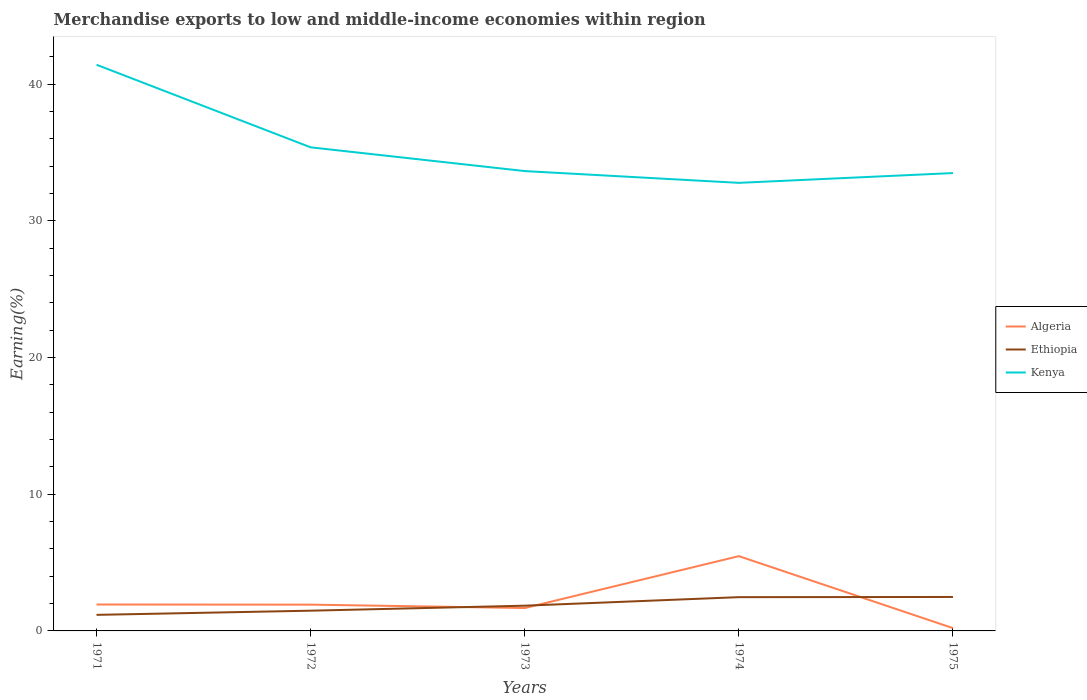How many different coloured lines are there?
Make the answer very short. 3. Across all years, what is the maximum percentage of amount earned from merchandise exports in Kenya?
Provide a short and direct response. 32.78. In which year was the percentage of amount earned from merchandise exports in Kenya maximum?
Provide a succinct answer. 1974. What is the total percentage of amount earned from merchandise exports in Kenya in the graph?
Your response must be concise. 0.86. What is the difference between the highest and the second highest percentage of amount earned from merchandise exports in Algeria?
Your answer should be very brief. 5.27. What is the difference between the highest and the lowest percentage of amount earned from merchandise exports in Ethiopia?
Ensure brevity in your answer.  2. How many lines are there?
Provide a succinct answer. 3. What is the difference between two consecutive major ticks on the Y-axis?
Provide a short and direct response. 10. Does the graph contain grids?
Give a very brief answer. No. Where does the legend appear in the graph?
Offer a terse response. Center right. What is the title of the graph?
Provide a short and direct response. Merchandise exports to low and middle-income economies within region. Does "Guam" appear as one of the legend labels in the graph?
Provide a short and direct response. No. What is the label or title of the Y-axis?
Offer a very short reply. Earning(%). What is the Earning(%) of Algeria in 1971?
Offer a very short reply. 1.93. What is the Earning(%) in Ethiopia in 1971?
Make the answer very short. 1.17. What is the Earning(%) of Kenya in 1971?
Provide a short and direct response. 41.42. What is the Earning(%) of Algeria in 1972?
Offer a very short reply. 1.92. What is the Earning(%) of Ethiopia in 1972?
Provide a succinct answer. 1.48. What is the Earning(%) in Kenya in 1972?
Offer a terse response. 35.38. What is the Earning(%) in Algeria in 1973?
Make the answer very short. 1.67. What is the Earning(%) of Ethiopia in 1973?
Your answer should be compact. 1.85. What is the Earning(%) of Kenya in 1973?
Your answer should be very brief. 33.64. What is the Earning(%) in Algeria in 1974?
Offer a terse response. 5.47. What is the Earning(%) in Ethiopia in 1974?
Make the answer very short. 2.47. What is the Earning(%) in Kenya in 1974?
Provide a succinct answer. 32.78. What is the Earning(%) of Algeria in 1975?
Give a very brief answer. 0.21. What is the Earning(%) of Ethiopia in 1975?
Your response must be concise. 2.48. What is the Earning(%) of Kenya in 1975?
Offer a very short reply. 33.49. Across all years, what is the maximum Earning(%) in Algeria?
Offer a very short reply. 5.47. Across all years, what is the maximum Earning(%) in Ethiopia?
Make the answer very short. 2.48. Across all years, what is the maximum Earning(%) of Kenya?
Provide a succinct answer. 41.42. Across all years, what is the minimum Earning(%) of Algeria?
Offer a very short reply. 0.21. Across all years, what is the minimum Earning(%) of Ethiopia?
Provide a succinct answer. 1.17. Across all years, what is the minimum Earning(%) in Kenya?
Provide a succinct answer. 32.78. What is the total Earning(%) in Algeria in the graph?
Offer a very short reply. 11.2. What is the total Earning(%) of Ethiopia in the graph?
Ensure brevity in your answer.  9.45. What is the total Earning(%) of Kenya in the graph?
Provide a short and direct response. 176.71. What is the difference between the Earning(%) in Ethiopia in 1971 and that in 1972?
Offer a terse response. -0.3. What is the difference between the Earning(%) of Kenya in 1971 and that in 1972?
Your answer should be very brief. 6.04. What is the difference between the Earning(%) of Algeria in 1971 and that in 1973?
Ensure brevity in your answer.  0.26. What is the difference between the Earning(%) of Ethiopia in 1971 and that in 1973?
Give a very brief answer. -0.67. What is the difference between the Earning(%) of Kenya in 1971 and that in 1973?
Make the answer very short. 7.78. What is the difference between the Earning(%) in Algeria in 1971 and that in 1974?
Your response must be concise. -3.54. What is the difference between the Earning(%) in Ethiopia in 1971 and that in 1974?
Provide a short and direct response. -1.3. What is the difference between the Earning(%) of Kenya in 1971 and that in 1974?
Your response must be concise. 8.64. What is the difference between the Earning(%) in Algeria in 1971 and that in 1975?
Your response must be concise. 1.73. What is the difference between the Earning(%) in Ethiopia in 1971 and that in 1975?
Your answer should be very brief. -1.31. What is the difference between the Earning(%) in Kenya in 1971 and that in 1975?
Make the answer very short. 7.92. What is the difference between the Earning(%) in Algeria in 1972 and that in 1973?
Offer a terse response. 0.25. What is the difference between the Earning(%) in Ethiopia in 1972 and that in 1973?
Give a very brief answer. -0.37. What is the difference between the Earning(%) in Kenya in 1972 and that in 1973?
Give a very brief answer. 1.74. What is the difference between the Earning(%) of Algeria in 1972 and that in 1974?
Offer a terse response. -3.55. What is the difference between the Earning(%) in Ethiopia in 1972 and that in 1974?
Keep it short and to the point. -0.99. What is the difference between the Earning(%) in Kenya in 1972 and that in 1974?
Provide a short and direct response. 2.6. What is the difference between the Earning(%) in Algeria in 1972 and that in 1975?
Make the answer very short. 1.72. What is the difference between the Earning(%) in Ethiopia in 1972 and that in 1975?
Provide a short and direct response. -1. What is the difference between the Earning(%) of Kenya in 1972 and that in 1975?
Your answer should be compact. 1.88. What is the difference between the Earning(%) in Algeria in 1973 and that in 1974?
Keep it short and to the point. -3.8. What is the difference between the Earning(%) of Ethiopia in 1973 and that in 1974?
Ensure brevity in your answer.  -0.62. What is the difference between the Earning(%) in Kenya in 1973 and that in 1974?
Your answer should be compact. 0.86. What is the difference between the Earning(%) in Algeria in 1973 and that in 1975?
Give a very brief answer. 1.47. What is the difference between the Earning(%) in Ethiopia in 1973 and that in 1975?
Provide a succinct answer. -0.64. What is the difference between the Earning(%) of Kenya in 1973 and that in 1975?
Your response must be concise. 0.15. What is the difference between the Earning(%) of Algeria in 1974 and that in 1975?
Give a very brief answer. 5.27. What is the difference between the Earning(%) of Ethiopia in 1974 and that in 1975?
Your answer should be compact. -0.01. What is the difference between the Earning(%) of Kenya in 1974 and that in 1975?
Give a very brief answer. -0.72. What is the difference between the Earning(%) in Algeria in 1971 and the Earning(%) in Ethiopia in 1972?
Offer a terse response. 0.45. What is the difference between the Earning(%) of Algeria in 1971 and the Earning(%) of Kenya in 1972?
Ensure brevity in your answer.  -33.44. What is the difference between the Earning(%) in Ethiopia in 1971 and the Earning(%) in Kenya in 1972?
Your answer should be very brief. -34.2. What is the difference between the Earning(%) in Algeria in 1971 and the Earning(%) in Ethiopia in 1973?
Your answer should be compact. 0.09. What is the difference between the Earning(%) in Algeria in 1971 and the Earning(%) in Kenya in 1973?
Give a very brief answer. -31.71. What is the difference between the Earning(%) in Ethiopia in 1971 and the Earning(%) in Kenya in 1973?
Provide a short and direct response. -32.46. What is the difference between the Earning(%) of Algeria in 1971 and the Earning(%) of Ethiopia in 1974?
Provide a short and direct response. -0.54. What is the difference between the Earning(%) in Algeria in 1971 and the Earning(%) in Kenya in 1974?
Offer a very short reply. -30.85. What is the difference between the Earning(%) in Ethiopia in 1971 and the Earning(%) in Kenya in 1974?
Provide a succinct answer. -31.6. What is the difference between the Earning(%) of Algeria in 1971 and the Earning(%) of Ethiopia in 1975?
Give a very brief answer. -0.55. What is the difference between the Earning(%) in Algeria in 1971 and the Earning(%) in Kenya in 1975?
Make the answer very short. -31.56. What is the difference between the Earning(%) of Ethiopia in 1971 and the Earning(%) of Kenya in 1975?
Offer a very short reply. -32.32. What is the difference between the Earning(%) of Algeria in 1972 and the Earning(%) of Ethiopia in 1973?
Keep it short and to the point. 0.08. What is the difference between the Earning(%) in Algeria in 1972 and the Earning(%) in Kenya in 1973?
Your answer should be compact. -31.72. What is the difference between the Earning(%) in Ethiopia in 1972 and the Earning(%) in Kenya in 1973?
Provide a succinct answer. -32.16. What is the difference between the Earning(%) in Algeria in 1972 and the Earning(%) in Ethiopia in 1974?
Offer a terse response. -0.55. What is the difference between the Earning(%) in Algeria in 1972 and the Earning(%) in Kenya in 1974?
Offer a terse response. -30.86. What is the difference between the Earning(%) in Ethiopia in 1972 and the Earning(%) in Kenya in 1974?
Offer a terse response. -31.3. What is the difference between the Earning(%) of Algeria in 1972 and the Earning(%) of Ethiopia in 1975?
Make the answer very short. -0.56. What is the difference between the Earning(%) of Algeria in 1972 and the Earning(%) of Kenya in 1975?
Provide a short and direct response. -31.57. What is the difference between the Earning(%) of Ethiopia in 1972 and the Earning(%) of Kenya in 1975?
Your answer should be very brief. -32.01. What is the difference between the Earning(%) in Algeria in 1973 and the Earning(%) in Ethiopia in 1974?
Your answer should be compact. -0.8. What is the difference between the Earning(%) in Algeria in 1973 and the Earning(%) in Kenya in 1974?
Offer a very short reply. -31.1. What is the difference between the Earning(%) of Ethiopia in 1973 and the Earning(%) of Kenya in 1974?
Your answer should be compact. -30.93. What is the difference between the Earning(%) of Algeria in 1973 and the Earning(%) of Ethiopia in 1975?
Your answer should be very brief. -0.81. What is the difference between the Earning(%) in Algeria in 1973 and the Earning(%) in Kenya in 1975?
Your answer should be compact. -31.82. What is the difference between the Earning(%) in Ethiopia in 1973 and the Earning(%) in Kenya in 1975?
Offer a very short reply. -31.65. What is the difference between the Earning(%) of Algeria in 1974 and the Earning(%) of Ethiopia in 1975?
Make the answer very short. 2.99. What is the difference between the Earning(%) in Algeria in 1974 and the Earning(%) in Kenya in 1975?
Offer a very short reply. -28.02. What is the difference between the Earning(%) of Ethiopia in 1974 and the Earning(%) of Kenya in 1975?
Make the answer very short. -31.02. What is the average Earning(%) in Algeria per year?
Offer a very short reply. 2.24. What is the average Earning(%) in Ethiopia per year?
Offer a very short reply. 1.89. What is the average Earning(%) in Kenya per year?
Give a very brief answer. 35.34. In the year 1971, what is the difference between the Earning(%) of Algeria and Earning(%) of Ethiopia?
Your response must be concise. 0.76. In the year 1971, what is the difference between the Earning(%) of Algeria and Earning(%) of Kenya?
Your answer should be compact. -39.49. In the year 1971, what is the difference between the Earning(%) in Ethiopia and Earning(%) in Kenya?
Your answer should be very brief. -40.24. In the year 1972, what is the difference between the Earning(%) of Algeria and Earning(%) of Ethiopia?
Offer a terse response. 0.44. In the year 1972, what is the difference between the Earning(%) of Algeria and Earning(%) of Kenya?
Provide a short and direct response. -33.45. In the year 1972, what is the difference between the Earning(%) in Ethiopia and Earning(%) in Kenya?
Provide a succinct answer. -33.9. In the year 1973, what is the difference between the Earning(%) in Algeria and Earning(%) in Ethiopia?
Your answer should be compact. -0.17. In the year 1973, what is the difference between the Earning(%) in Algeria and Earning(%) in Kenya?
Offer a very short reply. -31.97. In the year 1973, what is the difference between the Earning(%) in Ethiopia and Earning(%) in Kenya?
Provide a short and direct response. -31.79. In the year 1974, what is the difference between the Earning(%) of Algeria and Earning(%) of Ethiopia?
Your answer should be very brief. 3. In the year 1974, what is the difference between the Earning(%) of Algeria and Earning(%) of Kenya?
Give a very brief answer. -27.31. In the year 1974, what is the difference between the Earning(%) in Ethiopia and Earning(%) in Kenya?
Keep it short and to the point. -30.31. In the year 1975, what is the difference between the Earning(%) in Algeria and Earning(%) in Ethiopia?
Offer a very short reply. -2.28. In the year 1975, what is the difference between the Earning(%) in Algeria and Earning(%) in Kenya?
Give a very brief answer. -33.29. In the year 1975, what is the difference between the Earning(%) in Ethiopia and Earning(%) in Kenya?
Make the answer very short. -31.01. What is the ratio of the Earning(%) in Ethiopia in 1971 to that in 1972?
Keep it short and to the point. 0.79. What is the ratio of the Earning(%) of Kenya in 1971 to that in 1972?
Your response must be concise. 1.17. What is the ratio of the Earning(%) of Algeria in 1971 to that in 1973?
Make the answer very short. 1.15. What is the ratio of the Earning(%) of Ethiopia in 1971 to that in 1973?
Keep it short and to the point. 0.64. What is the ratio of the Earning(%) in Kenya in 1971 to that in 1973?
Provide a succinct answer. 1.23. What is the ratio of the Earning(%) in Algeria in 1971 to that in 1974?
Offer a terse response. 0.35. What is the ratio of the Earning(%) of Ethiopia in 1971 to that in 1974?
Offer a terse response. 0.48. What is the ratio of the Earning(%) in Kenya in 1971 to that in 1974?
Offer a terse response. 1.26. What is the ratio of the Earning(%) of Algeria in 1971 to that in 1975?
Offer a very short reply. 9.41. What is the ratio of the Earning(%) of Ethiopia in 1971 to that in 1975?
Provide a short and direct response. 0.47. What is the ratio of the Earning(%) of Kenya in 1971 to that in 1975?
Ensure brevity in your answer.  1.24. What is the ratio of the Earning(%) in Algeria in 1972 to that in 1973?
Your response must be concise. 1.15. What is the ratio of the Earning(%) in Ethiopia in 1972 to that in 1973?
Your answer should be compact. 0.8. What is the ratio of the Earning(%) of Kenya in 1972 to that in 1973?
Provide a succinct answer. 1.05. What is the ratio of the Earning(%) in Algeria in 1972 to that in 1974?
Your response must be concise. 0.35. What is the ratio of the Earning(%) of Ethiopia in 1972 to that in 1974?
Offer a terse response. 0.6. What is the ratio of the Earning(%) of Kenya in 1972 to that in 1974?
Make the answer very short. 1.08. What is the ratio of the Earning(%) in Algeria in 1972 to that in 1975?
Keep it short and to the point. 9.36. What is the ratio of the Earning(%) in Ethiopia in 1972 to that in 1975?
Offer a very short reply. 0.6. What is the ratio of the Earning(%) of Kenya in 1972 to that in 1975?
Offer a terse response. 1.06. What is the ratio of the Earning(%) in Algeria in 1973 to that in 1974?
Keep it short and to the point. 0.31. What is the ratio of the Earning(%) of Ethiopia in 1973 to that in 1974?
Provide a short and direct response. 0.75. What is the ratio of the Earning(%) in Kenya in 1973 to that in 1974?
Offer a very short reply. 1.03. What is the ratio of the Earning(%) of Algeria in 1973 to that in 1975?
Offer a very short reply. 8.15. What is the ratio of the Earning(%) of Ethiopia in 1973 to that in 1975?
Offer a terse response. 0.74. What is the ratio of the Earning(%) of Kenya in 1973 to that in 1975?
Provide a succinct answer. 1. What is the ratio of the Earning(%) of Algeria in 1974 to that in 1975?
Provide a short and direct response. 26.64. What is the ratio of the Earning(%) of Ethiopia in 1974 to that in 1975?
Give a very brief answer. 0.99. What is the ratio of the Earning(%) of Kenya in 1974 to that in 1975?
Your answer should be very brief. 0.98. What is the difference between the highest and the second highest Earning(%) of Algeria?
Your response must be concise. 3.54. What is the difference between the highest and the second highest Earning(%) in Ethiopia?
Your response must be concise. 0.01. What is the difference between the highest and the second highest Earning(%) of Kenya?
Ensure brevity in your answer.  6.04. What is the difference between the highest and the lowest Earning(%) of Algeria?
Give a very brief answer. 5.27. What is the difference between the highest and the lowest Earning(%) of Ethiopia?
Offer a terse response. 1.31. What is the difference between the highest and the lowest Earning(%) of Kenya?
Offer a very short reply. 8.64. 